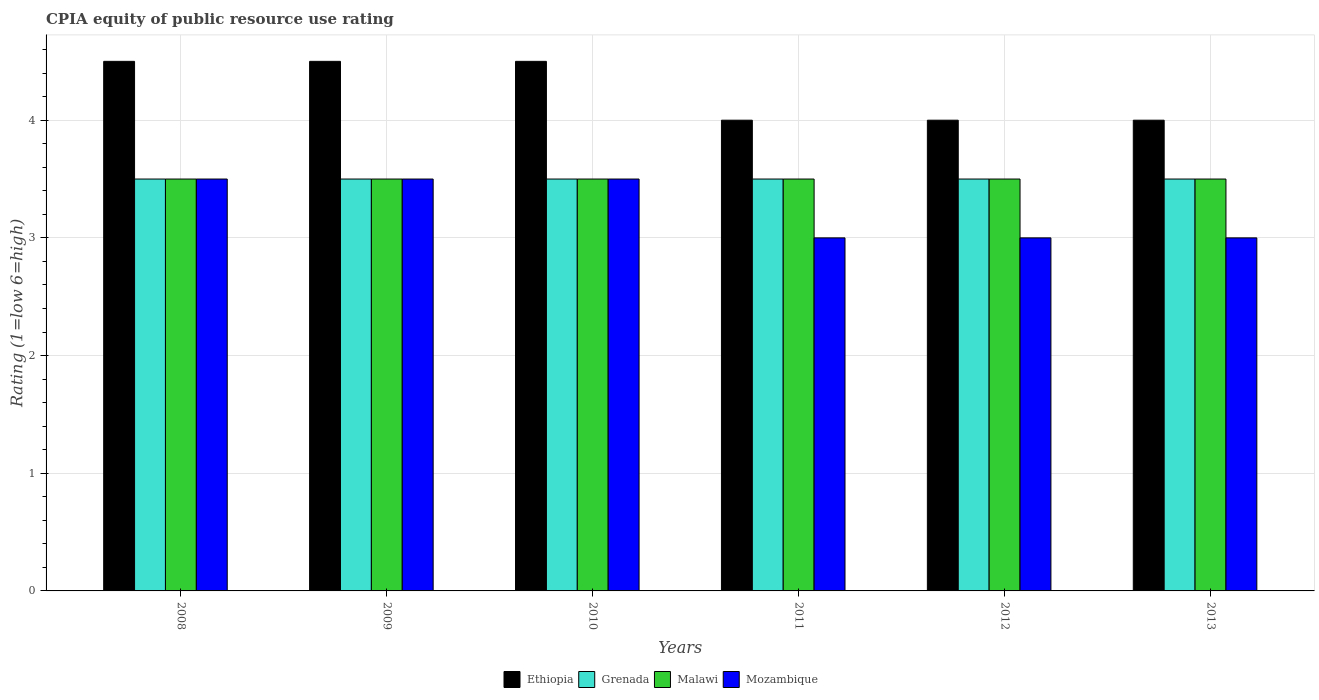How many groups of bars are there?
Give a very brief answer. 6. Are the number of bars per tick equal to the number of legend labels?
Offer a very short reply. Yes. Are the number of bars on each tick of the X-axis equal?
Ensure brevity in your answer.  Yes. How many bars are there on the 3rd tick from the left?
Your answer should be very brief. 4. Across all years, what is the maximum CPIA rating in Grenada?
Your response must be concise. 3.5. Across all years, what is the minimum CPIA rating in Grenada?
Give a very brief answer. 3.5. What is the total CPIA rating in Mozambique in the graph?
Ensure brevity in your answer.  19.5. What is the difference between the CPIA rating in Grenada in 2011 and that in 2013?
Your answer should be very brief. 0. What is the difference between the CPIA rating in Grenada in 2008 and the CPIA rating in Mozambique in 2012?
Ensure brevity in your answer.  0.5. In the year 2012, what is the difference between the CPIA rating in Ethiopia and CPIA rating in Grenada?
Ensure brevity in your answer.  0.5. Is the difference between the CPIA rating in Ethiopia in 2009 and 2013 greater than the difference between the CPIA rating in Grenada in 2009 and 2013?
Make the answer very short. Yes. What is the difference between the highest and the second highest CPIA rating in Malawi?
Offer a very short reply. 0. Is the sum of the CPIA rating in Malawi in 2008 and 2011 greater than the maximum CPIA rating in Grenada across all years?
Offer a terse response. Yes. What does the 1st bar from the left in 2010 represents?
Give a very brief answer. Ethiopia. What does the 4th bar from the right in 2009 represents?
Your answer should be very brief. Ethiopia. Is it the case that in every year, the sum of the CPIA rating in Malawi and CPIA rating in Ethiopia is greater than the CPIA rating in Mozambique?
Give a very brief answer. Yes. What is the difference between two consecutive major ticks on the Y-axis?
Keep it short and to the point. 1. Are the values on the major ticks of Y-axis written in scientific E-notation?
Provide a succinct answer. No. Does the graph contain any zero values?
Ensure brevity in your answer.  No. Does the graph contain grids?
Offer a very short reply. Yes. How many legend labels are there?
Make the answer very short. 4. What is the title of the graph?
Provide a succinct answer. CPIA equity of public resource use rating. What is the label or title of the X-axis?
Ensure brevity in your answer.  Years. What is the Rating (1=low 6=high) in Ethiopia in 2008?
Keep it short and to the point. 4.5. What is the Rating (1=low 6=high) of Malawi in 2008?
Ensure brevity in your answer.  3.5. What is the Rating (1=low 6=high) of Ethiopia in 2009?
Keep it short and to the point. 4.5. What is the Rating (1=low 6=high) in Ethiopia in 2010?
Keep it short and to the point. 4.5. What is the Rating (1=low 6=high) in Grenada in 2011?
Make the answer very short. 3.5. What is the Rating (1=low 6=high) of Mozambique in 2011?
Your answer should be very brief. 3. What is the Rating (1=low 6=high) of Ethiopia in 2012?
Your answer should be very brief. 4. What is the Rating (1=low 6=high) in Grenada in 2012?
Your answer should be very brief. 3.5. What is the Rating (1=low 6=high) in Malawi in 2012?
Ensure brevity in your answer.  3.5. What is the Rating (1=low 6=high) in Mozambique in 2012?
Keep it short and to the point. 3. What is the Rating (1=low 6=high) in Ethiopia in 2013?
Provide a succinct answer. 4. What is the Rating (1=low 6=high) of Grenada in 2013?
Offer a terse response. 3.5. What is the Rating (1=low 6=high) of Malawi in 2013?
Offer a very short reply. 3.5. What is the Rating (1=low 6=high) of Mozambique in 2013?
Offer a terse response. 3. Across all years, what is the minimum Rating (1=low 6=high) in Ethiopia?
Keep it short and to the point. 4. Across all years, what is the minimum Rating (1=low 6=high) of Malawi?
Your response must be concise. 3.5. Across all years, what is the minimum Rating (1=low 6=high) in Mozambique?
Provide a short and direct response. 3. What is the total Rating (1=low 6=high) of Grenada in the graph?
Give a very brief answer. 21. What is the total Rating (1=low 6=high) of Mozambique in the graph?
Your response must be concise. 19.5. What is the difference between the Rating (1=low 6=high) of Grenada in 2008 and that in 2009?
Provide a succinct answer. 0. What is the difference between the Rating (1=low 6=high) of Malawi in 2008 and that in 2009?
Make the answer very short. 0. What is the difference between the Rating (1=low 6=high) in Mozambique in 2008 and that in 2009?
Offer a terse response. 0. What is the difference between the Rating (1=low 6=high) of Ethiopia in 2008 and that in 2010?
Give a very brief answer. 0. What is the difference between the Rating (1=low 6=high) of Grenada in 2008 and that in 2010?
Offer a terse response. 0. What is the difference between the Rating (1=low 6=high) in Ethiopia in 2008 and that in 2011?
Your answer should be compact. 0.5. What is the difference between the Rating (1=low 6=high) in Ethiopia in 2008 and that in 2012?
Provide a succinct answer. 0.5. What is the difference between the Rating (1=low 6=high) in Grenada in 2008 and that in 2012?
Your answer should be compact. 0. What is the difference between the Rating (1=low 6=high) of Mozambique in 2008 and that in 2012?
Ensure brevity in your answer.  0.5. What is the difference between the Rating (1=low 6=high) in Ethiopia in 2008 and that in 2013?
Offer a very short reply. 0.5. What is the difference between the Rating (1=low 6=high) in Mozambique in 2008 and that in 2013?
Offer a very short reply. 0.5. What is the difference between the Rating (1=low 6=high) in Grenada in 2009 and that in 2010?
Your answer should be compact. 0. What is the difference between the Rating (1=low 6=high) of Mozambique in 2009 and that in 2010?
Offer a very short reply. 0. What is the difference between the Rating (1=low 6=high) in Grenada in 2009 and that in 2011?
Your answer should be compact. 0. What is the difference between the Rating (1=low 6=high) in Ethiopia in 2009 and that in 2012?
Keep it short and to the point. 0.5. What is the difference between the Rating (1=low 6=high) of Malawi in 2009 and that in 2012?
Offer a terse response. 0. What is the difference between the Rating (1=low 6=high) of Mozambique in 2009 and that in 2012?
Offer a very short reply. 0.5. What is the difference between the Rating (1=low 6=high) of Malawi in 2009 and that in 2013?
Your answer should be compact. 0. What is the difference between the Rating (1=low 6=high) in Ethiopia in 2010 and that in 2011?
Your response must be concise. 0.5. What is the difference between the Rating (1=low 6=high) in Grenada in 2010 and that in 2011?
Your response must be concise. 0. What is the difference between the Rating (1=low 6=high) in Malawi in 2010 and that in 2011?
Keep it short and to the point. 0. What is the difference between the Rating (1=low 6=high) of Ethiopia in 2010 and that in 2012?
Make the answer very short. 0.5. What is the difference between the Rating (1=low 6=high) of Malawi in 2010 and that in 2012?
Give a very brief answer. 0. What is the difference between the Rating (1=low 6=high) of Ethiopia in 2010 and that in 2013?
Ensure brevity in your answer.  0.5. What is the difference between the Rating (1=low 6=high) of Grenada in 2010 and that in 2013?
Make the answer very short. 0. What is the difference between the Rating (1=low 6=high) in Grenada in 2011 and that in 2012?
Provide a short and direct response. 0. What is the difference between the Rating (1=low 6=high) of Malawi in 2011 and that in 2012?
Your answer should be compact. 0. What is the difference between the Rating (1=low 6=high) of Mozambique in 2011 and that in 2012?
Your answer should be compact. 0. What is the difference between the Rating (1=low 6=high) of Ethiopia in 2011 and that in 2013?
Ensure brevity in your answer.  0. What is the difference between the Rating (1=low 6=high) of Malawi in 2011 and that in 2013?
Your response must be concise. 0. What is the difference between the Rating (1=low 6=high) in Grenada in 2012 and that in 2013?
Make the answer very short. 0. What is the difference between the Rating (1=low 6=high) of Ethiopia in 2008 and the Rating (1=low 6=high) of Grenada in 2009?
Make the answer very short. 1. What is the difference between the Rating (1=low 6=high) of Ethiopia in 2008 and the Rating (1=low 6=high) of Malawi in 2009?
Give a very brief answer. 1. What is the difference between the Rating (1=low 6=high) in Ethiopia in 2008 and the Rating (1=low 6=high) in Mozambique in 2009?
Provide a succinct answer. 1. What is the difference between the Rating (1=low 6=high) in Grenada in 2008 and the Rating (1=low 6=high) in Malawi in 2009?
Give a very brief answer. 0. What is the difference between the Rating (1=low 6=high) of Malawi in 2008 and the Rating (1=low 6=high) of Mozambique in 2009?
Your response must be concise. 0. What is the difference between the Rating (1=low 6=high) of Ethiopia in 2008 and the Rating (1=low 6=high) of Malawi in 2010?
Offer a very short reply. 1. What is the difference between the Rating (1=low 6=high) of Ethiopia in 2008 and the Rating (1=low 6=high) of Mozambique in 2010?
Make the answer very short. 1. What is the difference between the Rating (1=low 6=high) in Grenada in 2008 and the Rating (1=low 6=high) in Malawi in 2010?
Offer a terse response. 0. What is the difference between the Rating (1=low 6=high) of Grenada in 2008 and the Rating (1=low 6=high) of Mozambique in 2010?
Your answer should be very brief. 0. What is the difference between the Rating (1=low 6=high) in Malawi in 2008 and the Rating (1=low 6=high) in Mozambique in 2010?
Offer a very short reply. 0. What is the difference between the Rating (1=low 6=high) in Ethiopia in 2008 and the Rating (1=low 6=high) in Malawi in 2011?
Provide a short and direct response. 1. What is the difference between the Rating (1=low 6=high) of Ethiopia in 2008 and the Rating (1=low 6=high) of Grenada in 2012?
Make the answer very short. 1. What is the difference between the Rating (1=low 6=high) of Grenada in 2008 and the Rating (1=low 6=high) of Malawi in 2012?
Provide a succinct answer. 0. What is the difference between the Rating (1=low 6=high) of Grenada in 2008 and the Rating (1=low 6=high) of Malawi in 2013?
Your answer should be very brief. 0. What is the difference between the Rating (1=low 6=high) of Ethiopia in 2009 and the Rating (1=low 6=high) of Grenada in 2010?
Provide a short and direct response. 1. What is the difference between the Rating (1=low 6=high) of Ethiopia in 2009 and the Rating (1=low 6=high) of Mozambique in 2010?
Offer a very short reply. 1. What is the difference between the Rating (1=low 6=high) in Ethiopia in 2009 and the Rating (1=low 6=high) in Grenada in 2011?
Ensure brevity in your answer.  1. What is the difference between the Rating (1=low 6=high) in Ethiopia in 2009 and the Rating (1=low 6=high) in Mozambique in 2011?
Offer a very short reply. 1.5. What is the difference between the Rating (1=low 6=high) of Grenada in 2009 and the Rating (1=low 6=high) of Mozambique in 2011?
Provide a succinct answer. 0.5. What is the difference between the Rating (1=low 6=high) in Malawi in 2009 and the Rating (1=low 6=high) in Mozambique in 2011?
Provide a short and direct response. 0.5. What is the difference between the Rating (1=low 6=high) of Ethiopia in 2009 and the Rating (1=low 6=high) of Grenada in 2012?
Give a very brief answer. 1. What is the difference between the Rating (1=low 6=high) of Ethiopia in 2009 and the Rating (1=low 6=high) of Malawi in 2012?
Provide a succinct answer. 1. What is the difference between the Rating (1=low 6=high) of Grenada in 2009 and the Rating (1=low 6=high) of Mozambique in 2012?
Give a very brief answer. 0.5. What is the difference between the Rating (1=low 6=high) of Ethiopia in 2009 and the Rating (1=low 6=high) of Mozambique in 2013?
Your answer should be compact. 1.5. What is the difference between the Rating (1=low 6=high) in Grenada in 2009 and the Rating (1=low 6=high) in Mozambique in 2013?
Offer a terse response. 0.5. What is the difference between the Rating (1=low 6=high) of Ethiopia in 2010 and the Rating (1=low 6=high) of Grenada in 2011?
Provide a short and direct response. 1. What is the difference between the Rating (1=low 6=high) in Ethiopia in 2010 and the Rating (1=low 6=high) in Mozambique in 2011?
Ensure brevity in your answer.  1.5. What is the difference between the Rating (1=low 6=high) of Grenada in 2010 and the Rating (1=low 6=high) of Mozambique in 2011?
Provide a short and direct response. 0.5. What is the difference between the Rating (1=low 6=high) in Malawi in 2010 and the Rating (1=low 6=high) in Mozambique in 2011?
Offer a terse response. 0.5. What is the difference between the Rating (1=low 6=high) in Ethiopia in 2010 and the Rating (1=low 6=high) in Grenada in 2012?
Provide a short and direct response. 1. What is the difference between the Rating (1=low 6=high) of Ethiopia in 2010 and the Rating (1=low 6=high) of Malawi in 2012?
Offer a very short reply. 1. What is the difference between the Rating (1=low 6=high) in Ethiopia in 2010 and the Rating (1=low 6=high) in Mozambique in 2012?
Offer a very short reply. 1.5. What is the difference between the Rating (1=low 6=high) in Malawi in 2010 and the Rating (1=low 6=high) in Mozambique in 2012?
Keep it short and to the point. 0.5. What is the difference between the Rating (1=low 6=high) of Ethiopia in 2010 and the Rating (1=low 6=high) of Grenada in 2013?
Keep it short and to the point. 1. What is the difference between the Rating (1=low 6=high) in Ethiopia in 2010 and the Rating (1=low 6=high) in Mozambique in 2013?
Your answer should be very brief. 1.5. What is the difference between the Rating (1=low 6=high) in Grenada in 2010 and the Rating (1=low 6=high) in Mozambique in 2013?
Keep it short and to the point. 0.5. What is the difference between the Rating (1=low 6=high) of Ethiopia in 2011 and the Rating (1=low 6=high) of Grenada in 2012?
Your answer should be compact. 0.5. What is the difference between the Rating (1=low 6=high) of Ethiopia in 2011 and the Rating (1=low 6=high) of Malawi in 2012?
Keep it short and to the point. 0.5. What is the difference between the Rating (1=low 6=high) in Ethiopia in 2011 and the Rating (1=low 6=high) in Mozambique in 2012?
Give a very brief answer. 1. What is the difference between the Rating (1=low 6=high) in Grenada in 2011 and the Rating (1=low 6=high) in Malawi in 2012?
Offer a very short reply. 0. What is the difference between the Rating (1=low 6=high) in Malawi in 2011 and the Rating (1=low 6=high) in Mozambique in 2012?
Keep it short and to the point. 0.5. What is the difference between the Rating (1=low 6=high) of Ethiopia in 2011 and the Rating (1=low 6=high) of Grenada in 2013?
Your answer should be compact. 0.5. What is the difference between the Rating (1=low 6=high) in Ethiopia in 2011 and the Rating (1=low 6=high) in Mozambique in 2013?
Offer a very short reply. 1. What is the difference between the Rating (1=low 6=high) in Grenada in 2011 and the Rating (1=low 6=high) in Mozambique in 2013?
Offer a terse response. 0.5. What is the difference between the Rating (1=low 6=high) of Ethiopia in 2012 and the Rating (1=low 6=high) of Grenada in 2013?
Offer a very short reply. 0.5. What is the difference between the Rating (1=low 6=high) of Ethiopia in 2012 and the Rating (1=low 6=high) of Malawi in 2013?
Your response must be concise. 0.5. What is the difference between the Rating (1=low 6=high) of Malawi in 2012 and the Rating (1=low 6=high) of Mozambique in 2013?
Provide a short and direct response. 0.5. What is the average Rating (1=low 6=high) of Ethiopia per year?
Your answer should be compact. 4.25. What is the average Rating (1=low 6=high) in Malawi per year?
Give a very brief answer. 3.5. What is the average Rating (1=low 6=high) in Mozambique per year?
Offer a terse response. 3.25. In the year 2008, what is the difference between the Rating (1=low 6=high) of Malawi and Rating (1=low 6=high) of Mozambique?
Make the answer very short. 0. In the year 2009, what is the difference between the Rating (1=low 6=high) of Ethiopia and Rating (1=low 6=high) of Grenada?
Your response must be concise. 1. In the year 2009, what is the difference between the Rating (1=low 6=high) in Ethiopia and Rating (1=low 6=high) in Malawi?
Your answer should be very brief. 1. In the year 2009, what is the difference between the Rating (1=low 6=high) of Ethiopia and Rating (1=low 6=high) of Mozambique?
Keep it short and to the point. 1. In the year 2009, what is the difference between the Rating (1=low 6=high) of Grenada and Rating (1=low 6=high) of Malawi?
Ensure brevity in your answer.  0. In the year 2009, what is the difference between the Rating (1=low 6=high) in Grenada and Rating (1=low 6=high) in Mozambique?
Ensure brevity in your answer.  0. In the year 2010, what is the difference between the Rating (1=low 6=high) of Ethiopia and Rating (1=low 6=high) of Grenada?
Make the answer very short. 1. In the year 2010, what is the difference between the Rating (1=low 6=high) of Ethiopia and Rating (1=low 6=high) of Malawi?
Provide a short and direct response. 1. In the year 2010, what is the difference between the Rating (1=low 6=high) in Ethiopia and Rating (1=low 6=high) in Mozambique?
Provide a short and direct response. 1. In the year 2010, what is the difference between the Rating (1=low 6=high) of Grenada and Rating (1=low 6=high) of Malawi?
Provide a short and direct response. 0. In the year 2010, what is the difference between the Rating (1=low 6=high) in Grenada and Rating (1=low 6=high) in Mozambique?
Your answer should be compact. 0. In the year 2010, what is the difference between the Rating (1=low 6=high) of Malawi and Rating (1=low 6=high) of Mozambique?
Make the answer very short. 0. In the year 2011, what is the difference between the Rating (1=low 6=high) of Ethiopia and Rating (1=low 6=high) of Grenada?
Keep it short and to the point. 0.5. In the year 2011, what is the difference between the Rating (1=low 6=high) of Ethiopia and Rating (1=low 6=high) of Malawi?
Make the answer very short. 0.5. In the year 2011, what is the difference between the Rating (1=low 6=high) of Grenada and Rating (1=low 6=high) of Mozambique?
Offer a terse response. 0.5. In the year 2011, what is the difference between the Rating (1=low 6=high) in Malawi and Rating (1=low 6=high) in Mozambique?
Offer a very short reply. 0.5. In the year 2012, what is the difference between the Rating (1=low 6=high) of Ethiopia and Rating (1=low 6=high) of Grenada?
Your answer should be very brief. 0.5. In the year 2012, what is the difference between the Rating (1=low 6=high) of Grenada and Rating (1=low 6=high) of Malawi?
Give a very brief answer. 0. In the year 2013, what is the difference between the Rating (1=low 6=high) in Ethiopia and Rating (1=low 6=high) in Grenada?
Your answer should be compact. 0.5. In the year 2013, what is the difference between the Rating (1=low 6=high) in Ethiopia and Rating (1=low 6=high) in Malawi?
Your answer should be very brief. 0.5. In the year 2013, what is the difference between the Rating (1=low 6=high) of Ethiopia and Rating (1=low 6=high) of Mozambique?
Provide a short and direct response. 1. In the year 2013, what is the difference between the Rating (1=low 6=high) of Grenada and Rating (1=low 6=high) of Malawi?
Provide a succinct answer. 0. In the year 2013, what is the difference between the Rating (1=low 6=high) of Malawi and Rating (1=low 6=high) of Mozambique?
Offer a very short reply. 0.5. What is the ratio of the Rating (1=low 6=high) in Ethiopia in 2008 to that in 2009?
Provide a succinct answer. 1. What is the ratio of the Rating (1=low 6=high) in Malawi in 2008 to that in 2009?
Keep it short and to the point. 1. What is the ratio of the Rating (1=low 6=high) of Ethiopia in 2008 to that in 2010?
Offer a very short reply. 1. What is the ratio of the Rating (1=low 6=high) of Grenada in 2008 to that in 2010?
Your answer should be compact. 1. What is the ratio of the Rating (1=low 6=high) of Grenada in 2008 to that in 2011?
Keep it short and to the point. 1. What is the ratio of the Rating (1=low 6=high) in Mozambique in 2008 to that in 2011?
Make the answer very short. 1.17. What is the ratio of the Rating (1=low 6=high) of Malawi in 2008 to that in 2012?
Keep it short and to the point. 1. What is the ratio of the Rating (1=low 6=high) in Mozambique in 2008 to that in 2012?
Offer a terse response. 1.17. What is the ratio of the Rating (1=low 6=high) in Malawi in 2008 to that in 2013?
Make the answer very short. 1. What is the ratio of the Rating (1=low 6=high) in Mozambique in 2008 to that in 2013?
Offer a very short reply. 1.17. What is the ratio of the Rating (1=low 6=high) in Ethiopia in 2009 to that in 2010?
Provide a succinct answer. 1. What is the ratio of the Rating (1=low 6=high) of Malawi in 2009 to that in 2010?
Offer a terse response. 1. What is the ratio of the Rating (1=low 6=high) of Mozambique in 2009 to that in 2010?
Give a very brief answer. 1. What is the ratio of the Rating (1=low 6=high) of Ethiopia in 2009 to that in 2011?
Ensure brevity in your answer.  1.12. What is the ratio of the Rating (1=low 6=high) of Grenada in 2009 to that in 2011?
Provide a succinct answer. 1. What is the ratio of the Rating (1=low 6=high) of Ethiopia in 2009 to that in 2012?
Provide a succinct answer. 1.12. What is the ratio of the Rating (1=low 6=high) of Grenada in 2009 to that in 2012?
Ensure brevity in your answer.  1. What is the ratio of the Rating (1=low 6=high) in Malawi in 2009 to that in 2012?
Ensure brevity in your answer.  1. What is the ratio of the Rating (1=low 6=high) of Ethiopia in 2009 to that in 2013?
Your answer should be compact. 1.12. What is the ratio of the Rating (1=low 6=high) in Malawi in 2009 to that in 2013?
Your answer should be very brief. 1. What is the ratio of the Rating (1=low 6=high) in Mozambique in 2009 to that in 2013?
Provide a succinct answer. 1.17. What is the ratio of the Rating (1=low 6=high) in Ethiopia in 2010 to that in 2011?
Your answer should be compact. 1.12. What is the ratio of the Rating (1=low 6=high) in Grenada in 2010 to that in 2011?
Give a very brief answer. 1. What is the ratio of the Rating (1=low 6=high) of Malawi in 2010 to that in 2011?
Ensure brevity in your answer.  1. What is the ratio of the Rating (1=low 6=high) of Mozambique in 2010 to that in 2011?
Keep it short and to the point. 1.17. What is the ratio of the Rating (1=low 6=high) in Malawi in 2010 to that in 2012?
Make the answer very short. 1. What is the ratio of the Rating (1=low 6=high) in Ethiopia in 2010 to that in 2013?
Provide a succinct answer. 1.12. What is the ratio of the Rating (1=low 6=high) in Grenada in 2010 to that in 2013?
Keep it short and to the point. 1. What is the ratio of the Rating (1=low 6=high) of Malawi in 2010 to that in 2013?
Give a very brief answer. 1. What is the ratio of the Rating (1=low 6=high) in Mozambique in 2010 to that in 2013?
Provide a short and direct response. 1.17. What is the ratio of the Rating (1=low 6=high) of Ethiopia in 2011 to that in 2012?
Offer a very short reply. 1. What is the ratio of the Rating (1=low 6=high) in Malawi in 2011 to that in 2012?
Give a very brief answer. 1. What is the ratio of the Rating (1=low 6=high) of Malawi in 2011 to that in 2013?
Give a very brief answer. 1. What is the ratio of the Rating (1=low 6=high) in Mozambique in 2011 to that in 2013?
Make the answer very short. 1. What is the ratio of the Rating (1=low 6=high) of Grenada in 2012 to that in 2013?
Offer a very short reply. 1. What is the ratio of the Rating (1=low 6=high) of Malawi in 2012 to that in 2013?
Ensure brevity in your answer.  1. What is the ratio of the Rating (1=low 6=high) in Mozambique in 2012 to that in 2013?
Make the answer very short. 1. What is the difference between the highest and the second highest Rating (1=low 6=high) in Ethiopia?
Provide a succinct answer. 0. What is the difference between the highest and the second highest Rating (1=low 6=high) in Grenada?
Your answer should be very brief. 0. What is the difference between the highest and the lowest Rating (1=low 6=high) in Grenada?
Provide a short and direct response. 0. What is the difference between the highest and the lowest Rating (1=low 6=high) of Malawi?
Make the answer very short. 0. 